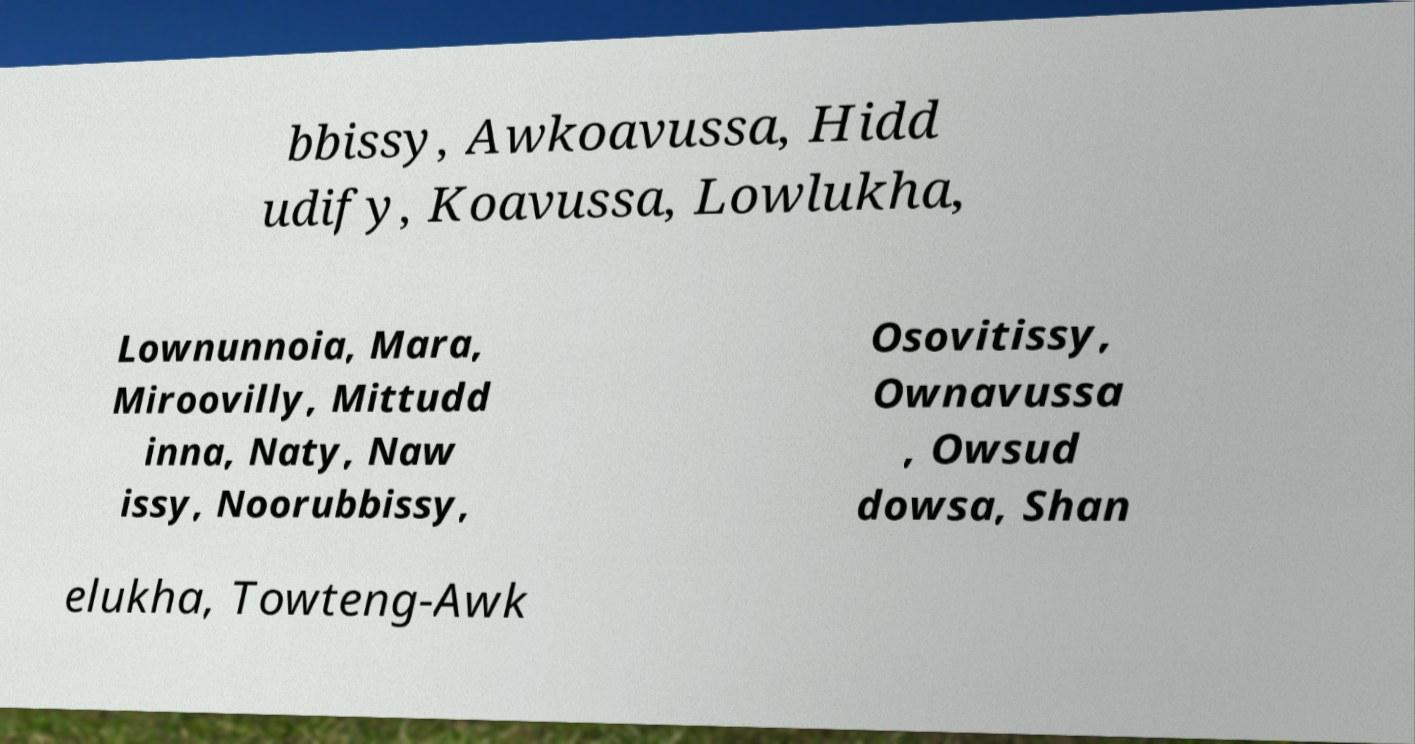Can you read and provide the text displayed in the image?This photo seems to have some interesting text. Can you extract and type it out for me? bbissy, Awkoavussa, Hidd udify, Koavussa, Lowlukha, Lownunnoia, Mara, Miroovilly, Mittudd inna, Naty, Naw issy, Noorubbissy, Osovitissy, Ownavussa , Owsud dowsa, Shan elukha, Towteng-Awk 